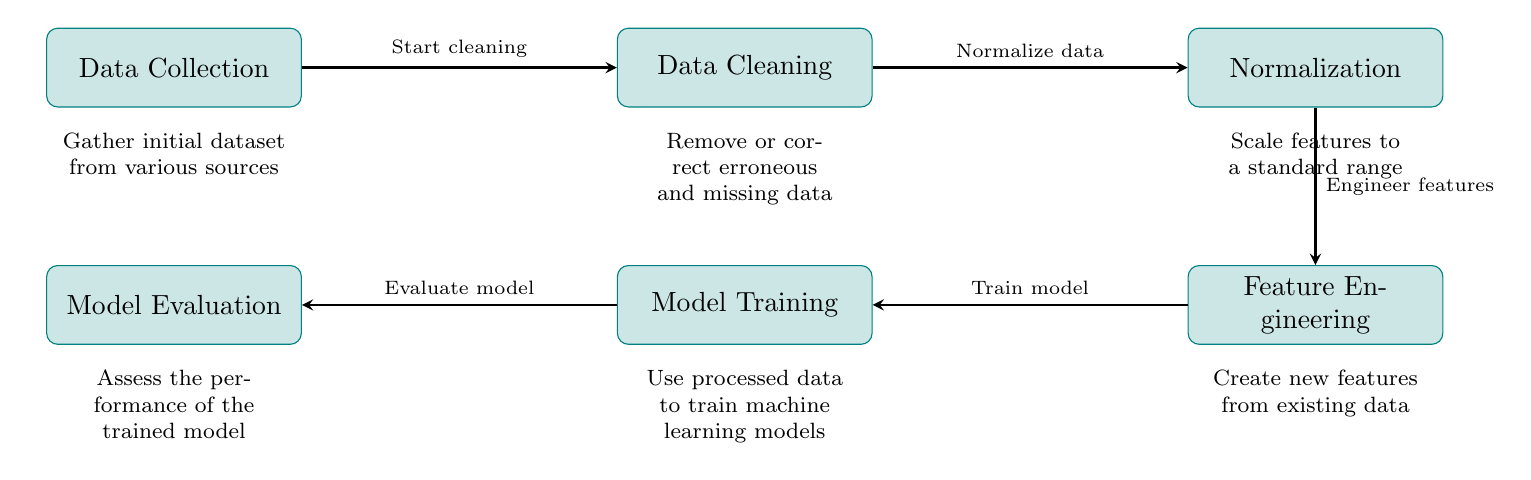What is the first stage in the diagram? The first stage in the diagram is labeled as "Data Collection," which indicates the initial step in the data preprocessing flow.
Answer: Data Collection How many main stages are depicted in the diagram? The diagram displays a total of six main stages, each represented by a distinct process box.
Answer: Six What action is performed after Data Cleaning? After Data Cleaning, the next action in the diagram is "Normalization," as shown by the arrow indicating the flow from one process to the next.
Answer: Normalization What is the purpose of Feature Engineering? The purpose of Feature Engineering, as described in the diagram, is to "Create new features from existing data," which is an essential step for improving model performance.
Answer: Create new features from existing data Which stage follows Model Training? The stage that follows Model Training is "Model Evaluation," which assesses the performance of the trained model according to the diagram.
Answer: Model Evaluation How does Data Cleaning relate to Data Collection? Data Cleaning is a subsequent step that directly follows Data Collection, indicating that it is the next necessary action after collecting initial data.
Answer: Start cleaning What is the connection between Normalization and Feature Engineering? Normalization is a prerequisite for Feature Engineering, as they are sequential stages in the preprocessing process, with Normalization leading into Feature Engineering.
Answer: Engineer features What happens to the processed data during Model Training? During Model Training, the processed data is used to train machine learning models, as specified in the diagram.
Answer: Use processed data to train machine learning models What specific task is assigned to Model Evaluation? The specific task of Model Evaluation is to assess the performance of the trained model, which is clearly outlined in the diagram.
Answer: Assess the performance of the trained model 